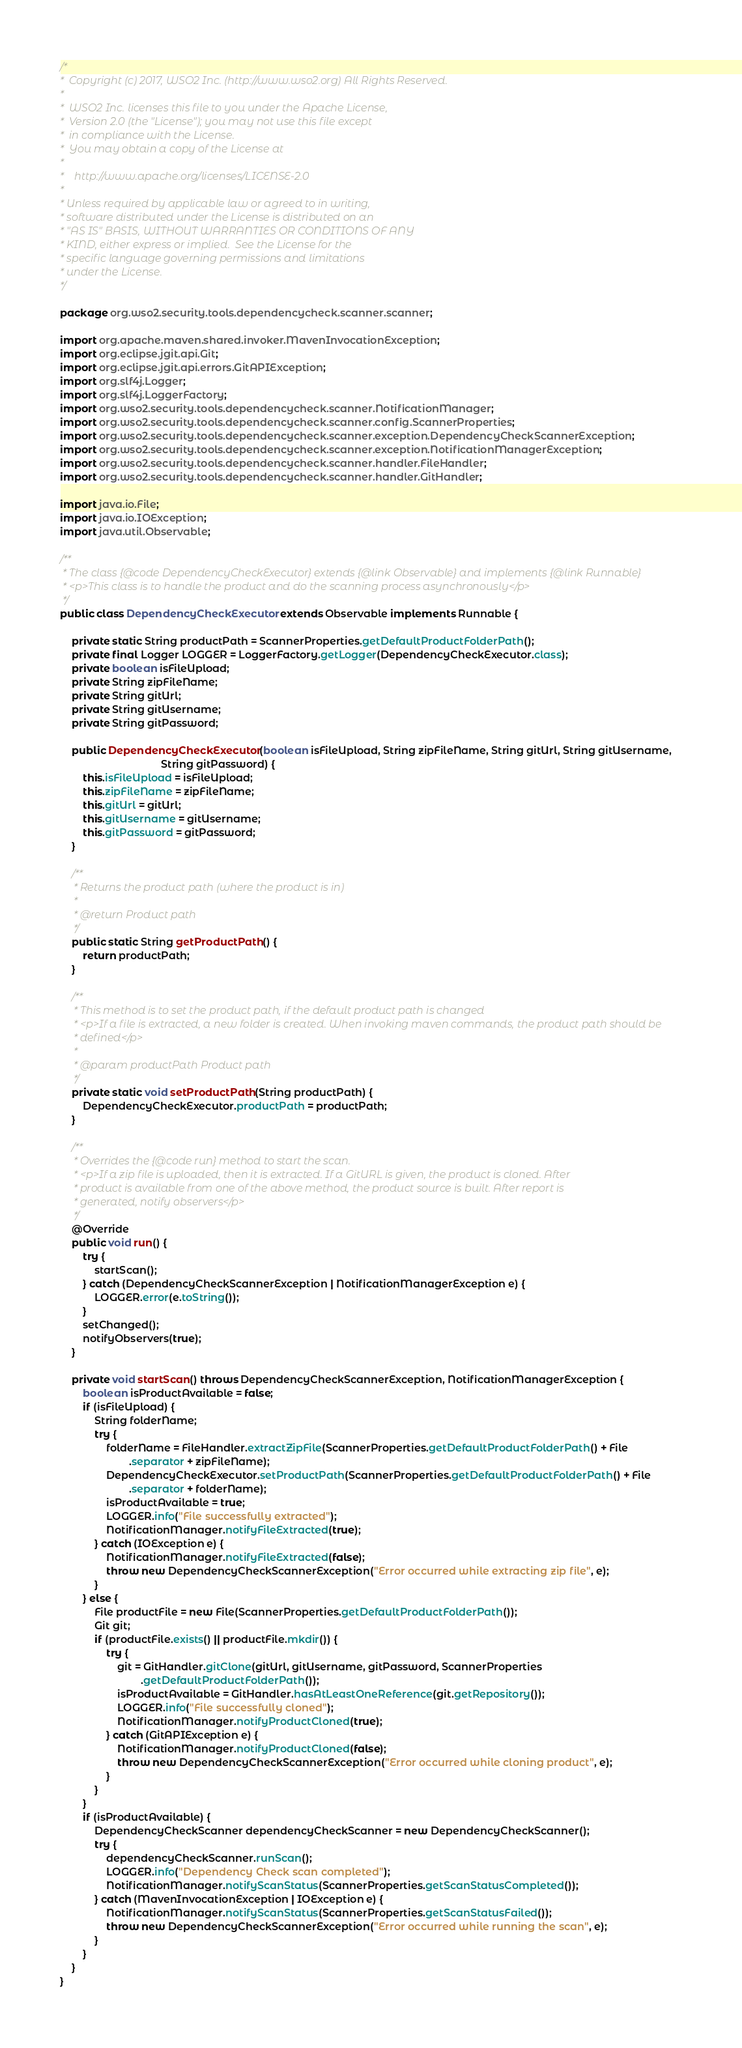Convert code to text. <code><loc_0><loc_0><loc_500><loc_500><_Java_>/*
*  Copyright (c) 2017, WSO2 Inc. (http://www.wso2.org) All Rights Reserved.
*
*  WSO2 Inc. licenses this file to you under the Apache License,
*  Version 2.0 (the "License"); you may not use this file except
*  in compliance with the License.
*  You may obtain a copy of the License at
*
*    http://www.apache.org/licenses/LICENSE-2.0
*
* Unless required by applicable law or agreed to in writing,
* software distributed under the License is distributed on an
* "AS IS" BASIS, WITHOUT WARRANTIES OR CONDITIONS OF ANY
* KIND, either express or implied.  See the License for the
* specific language governing permissions and limitations
* under the License.
*/

package org.wso2.security.tools.dependencycheck.scanner.scanner;

import org.apache.maven.shared.invoker.MavenInvocationException;
import org.eclipse.jgit.api.Git;
import org.eclipse.jgit.api.errors.GitAPIException;
import org.slf4j.Logger;
import org.slf4j.LoggerFactory;
import org.wso2.security.tools.dependencycheck.scanner.NotificationManager;
import org.wso2.security.tools.dependencycheck.scanner.config.ScannerProperties;
import org.wso2.security.tools.dependencycheck.scanner.exception.DependencyCheckScannerException;
import org.wso2.security.tools.dependencycheck.scanner.exception.NotificationManagerException;
import org.wso2.security.tools.dependencycheck.scanner.handler.FileHandler;
import org.wso2.security.tools.dependencycheck.scanner.handler.GitHandler;

import java.io.File;
import java.io.IOException;
import java.util.Observable;

/**
 * The class {@code DependencyCheckExecutor} extends {@link Observable} and implements {@link Runnable}
 * <p>This class is to handle the product and do the scanning process asynchronously</p>
 */
public class DependencyCheckExecutor extends Observable implements Runnable {

    private static String productPath = ScannerProperties.getDefaultProductFolderPath();
    private final Logger LOGGER = LoggerFactory.getLogger(DependencyCheckExecutor.class);
    private boolean isFileUpload;
    private String zipFileName;
    private String gitUrl;
    private String gitUsername;
    private String gitPassword;

    public DependencyCheckExecutor(boolean isFileUpload, String zipFileName, String gitUrl, String gitUsername,
                                   String gitPassword) {
        this.isFileUpload = isFileUpload;
        this.zipFileName = zipFileName;
        this.gitUrl = gitUrl;
        this.gitUsername = gitUsername;
        this.gitPassword = gitPassword;
    }

    /**
     * Returns the product path (where the product is in)
     *
     * @return Product path
     */
    public static String getProductPath() {
        return productPath;
    }

    /**
     * This method is to set the product path, if the default product path is changed
     * <p>If a file is extracted, a new folder is created. When invoking maven commands, the product path should be
     * defined</p>
     *
     * @param productPath Product path
     */
    private static void setProductPath(String productPath) {
        DependencyCheckExecutor.productPath = productPath;
    }

    /**
     * Overrides the {@code run} method to start the scan.
     * <p>If a zip file is uploaded, then it is extracted. If a GitURL is given, the product is cloned. After
     * product is available from one of the above method, the product source is built. After report is
     * generated, notify observers</p>
     */
    @Override
    public void run() {
        try {
            startScan();
        } catch (DependencyCheckScannerException | NotificationManagerException e) {
            LOGGER.error(e.toString());
        }
        setChanged();
        notifyObservers(true);
    }

    private void startScan() throws DependencyCheckScannerException, NotificationManagerException {
        boolean isProductAvailable = false;
        if (isFileUpload) {
            String folderName;
            try {
                folderName = FileHandler.extractZipFile(ScannerProperties.getDefaultProductFolderPath() + File
                        .separator + zipFileName);
                DependencyCheckExecutor.setProductPath(ScannerProperties.getDefaultProductFolderPath() + File
                        .separator + folderName);
                isProductAvailable = true;
                LOGGER.info("File successfully extracted");
                NotificationManager.notifyFileExtracted(true);
            } catch (IOException e) {
                NotificationManager.notifyFileExtracted(false);
                throw new DependencyCheckScannerException("Error occurred while extracting zip file", e);
            }
        } else {
            File productFile = new File(ScannerProperties.getDefaultProductFolderPath());
            Git git;
            if (productFile.exists() || productFile.mkdir()) {
                try {
                    git = GitHandler.gitClone(gitUrl, gitUsername, gitPassword, ScannerProperties
                            .getDefaultProductFolderPath());
                    isProductAvailable = GitHandler.hasAtLeastOneReference(git.getRepository());
                    LOGGER.info("File successfully cloned");
                    NotificationManager.notifyProductCloned(true);
                } catch (GitAPIException e) {
                    NotificationManager.notifyProductCloned(false);
                    throw new DependencyCheckScannerException("Error occurred while cloning product", e);
                }
            }
        }
        if (isProductAvailable) {
            DependencyCheckScanner dependencyCheckScanner = new DependencyCheckScanner();
            try {
                dependencyCheckScanner.runScan();
                LOGGER.info("Dependency Check scan completed");
                NotificationManager.notifyScanStatus(ScannerProperties.getScanStatusCompleted());
            } catch (MavenInvocationException | IOException e) {
                NotificationManager.notifyScanStatus(ScannerProperties.getScanStatusFailed());
                throw new DependencyCheckScannerException("Error occurred while running the scan", e);
            }
        }
    }
}

</code> 